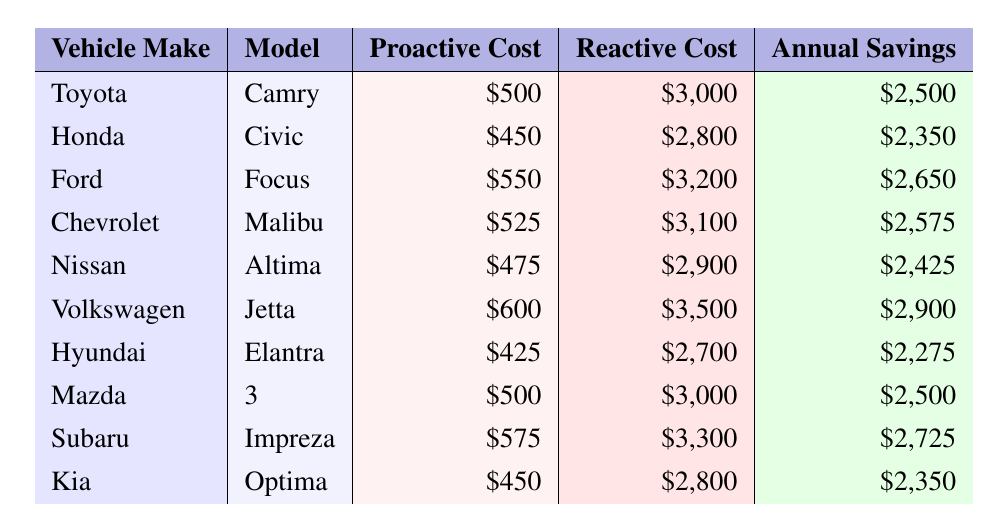What is the estimated annual savings for a Toyota Camry? According to the table, the estimated annual savings for a Toyota Camry is listed as $2,500.
Answer: $2,500 What is the proactive replacement cost for a Honda Civic? The table shows that the proactive replacement cost for a Honda Civic is $450.
Answer: $450 Which vehicle make and model has the highest reactive repair cost? By looking at the reactive repair costs, the Volkswagen Jetta has the highest reactive repair cost at $3,500.
Answer: Volkswagen Jetta How much can an owner save annually on average when proactively replacing timing belts across all models listed? First, sum all estimated annual savings: $2,500 + $2,350 + $2,650 + $2,575 + $2,425 + $2,900 + $2,275 + $2,500 + $2,725 + $2,350 = $27,850. Then divide by 10 data points to get the average: $27,850 / 10 = $2,785.
Answer: $2,785 Does proactive replacement cost for a Hyundai Elantra exceed $400? The proactive replacement cost for a Hyundai Elantra is $425, which does exceed $400.
Answer: Yes What is the difference in estimated annual savings between the Ford Focus and the Kia Optima? The estimated annual savings for the Ford Focus is $2,650 and for the Kia Optima is $2,350. The difference is $2,650 - $2,350 = $300.
Answer: $300 Is the estimated annual savings for the Chevrolet Malibu more than that for the Nissan Altima? The estimated annual savings for Chevrolet Malibu is $2,575 and for Nissan Altima is $2,425. Since $2,575 is greater than $2,425, the statement is true.
Answer: Yes If two vehicles, Volkswagen Jetta and Subaru Impreza, were to be combined, what would their total reactive repair cost be? Volkswagen Jetta has a reactive repair cost of $3,500 and Subaru Impreza has $3,300. Adding them gives $3,500 + $3,300 = $6,800.
Answer: $6,800 Which vehicle has the lowest proactive replacement cost and what is that cost? The Hyundai Elantra has the lowest proactive replacement cost of $425, as seen in the table.
Answer: $425 What is the average proactive replacement cost for all the vehicles listed? First, sum all proactive replacement costs: $500 + $450 + $550 + $525 + $475 + $600 + $425 + $500 + $575 + $450 = $5,250. Then divide by 10: $5,250 / 10 = $525.
Answer: $525 